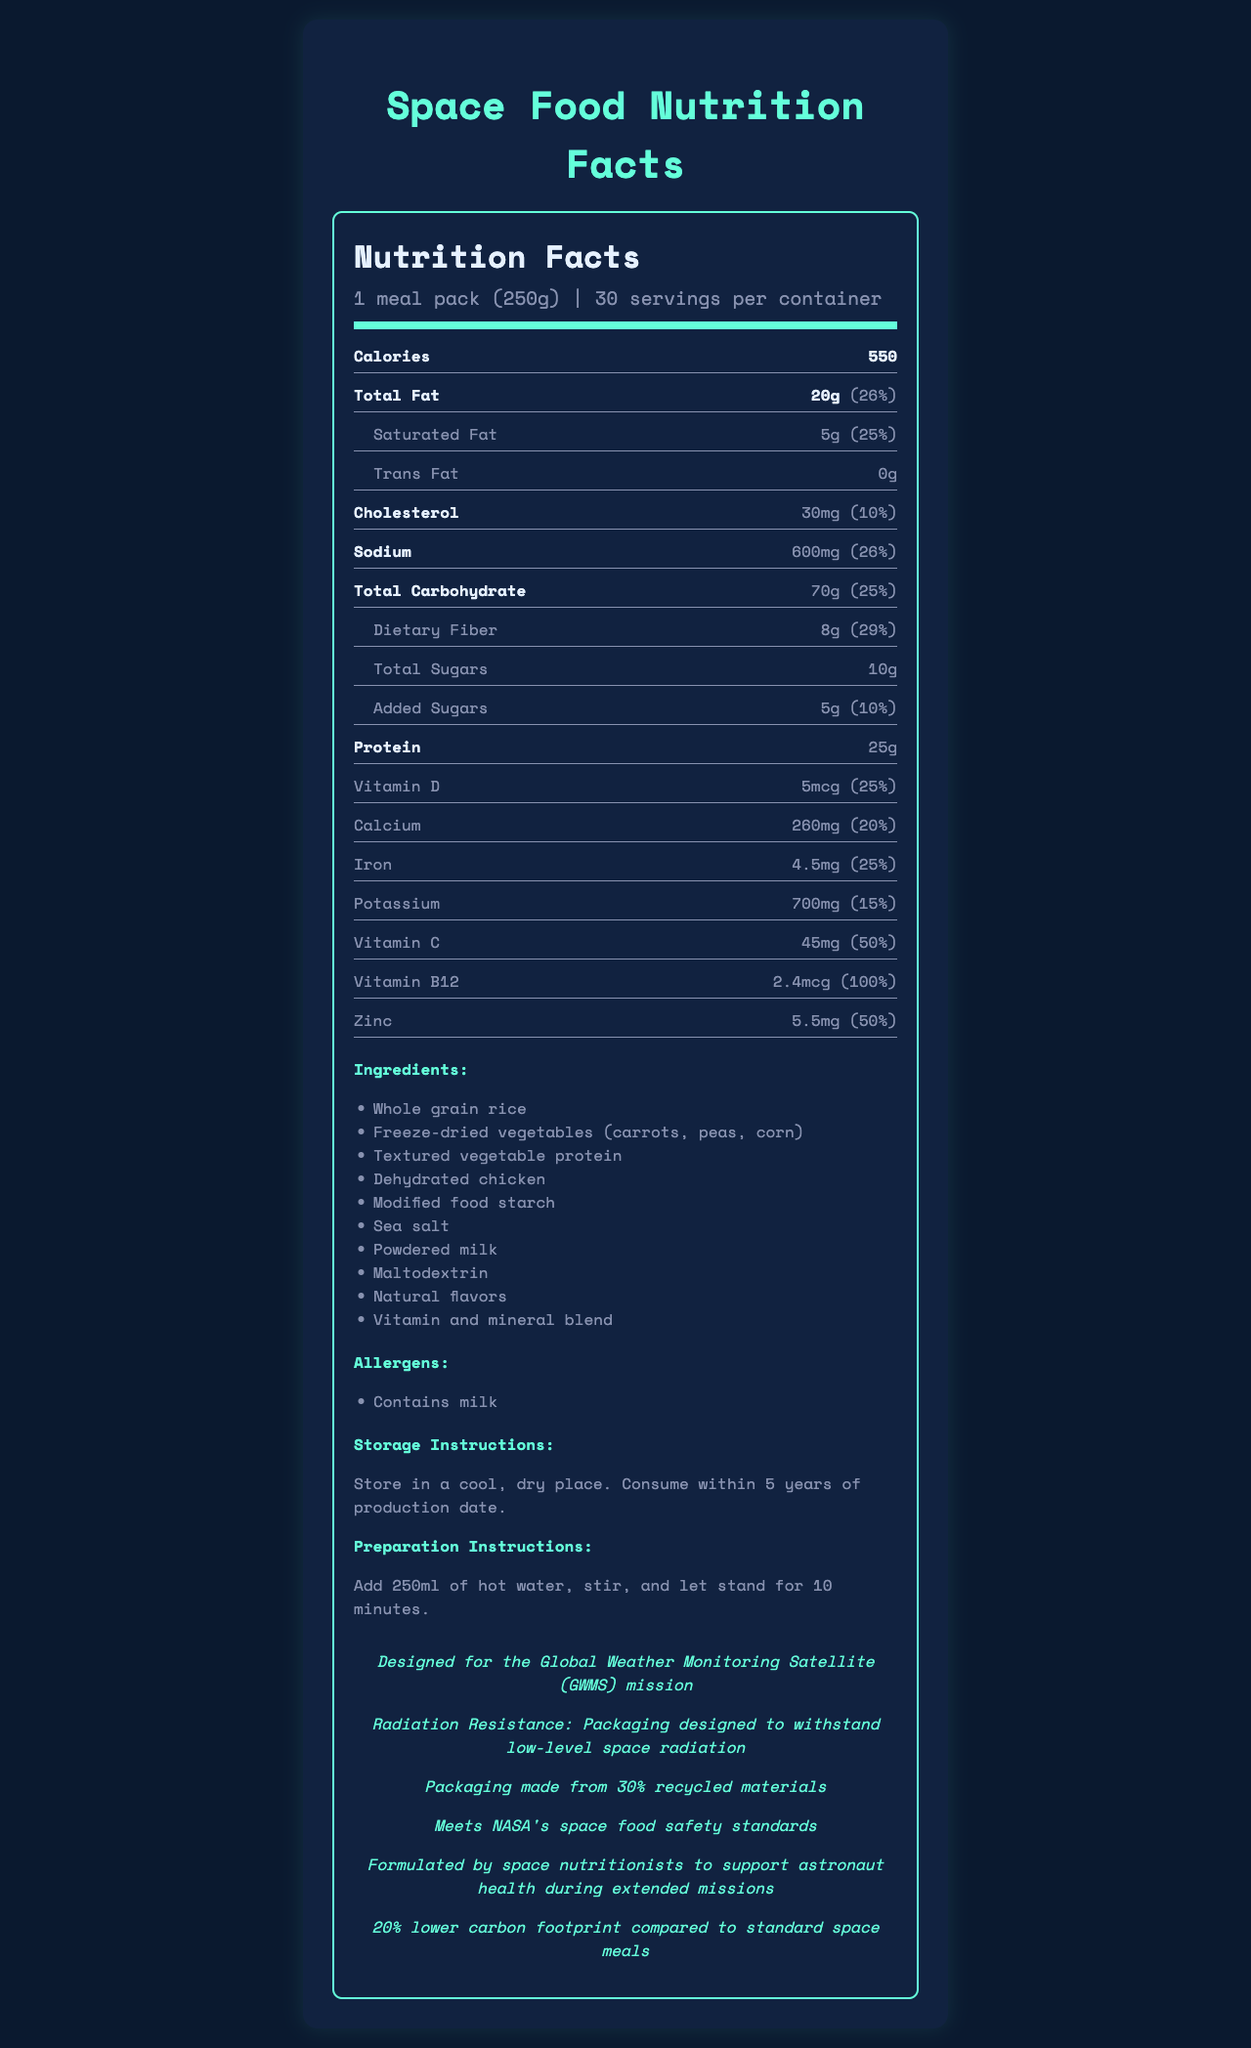what is the serving size of the meal pack? The serving size is clearly mentioned at the beginning of the document as "1 meal pack (250g)".
Answer: 1 meal pack (250g) how many servings are there per container? According to the document, each container has 30 servings.
Answer: 30 how many calories are there per serving? The document specifies that each serving contains 550 calories.
Answer: 550 calories what is the amount of protein per serving? Under the nutrition facts, the amount of protein is listed as 25g per serving.
Answer: 25g what is the percentage daily value of saturated fat per serving? The document indicates that the daily value percentage for saturated fat per serving is 25%.
Answer: 25% what are the storage instructions for the meal pack? The storage instructions are provided in the section near the end of the document.
Answer: Store in a cool, dry place. Consume within 5 years of production date. what are the main ingredients listed for the meal pack? The document has a detailed list of ingredients under the Ingredients section.
Answer: Whole grain rice, Freeze-dried vegetables (carrots, peas, corn), Textured vegetable protein, Dehydrated chicken, Modified food starch, Sea salt, Powdered milk, Maltodextrin, Natural flavors, Vitamin and mineral blend how many grams of total fat are there in a serving? The total fat content per serving is mentioned as 20g in the nutrition facts.
Answer: 20g how much sodium is in each serving? Sodium content per serving is stated as 600mg.
Answer: 600mg which vitamin has the highest daily value percentage in a single serving? A. Vitamin D B. Calcium C. Vitamin B12 D. Zinc The daily value percentage for Vitamin B12 is 100%, which is higher than the other listed vitamins.
Answer: C. Vitamin B12 which one of the following ingredients is NOT in the meal pack? i. Carrots ii. Peas iii. Beef The document lists the ingredients, and beef is not one of them, whereas carrots and peas are included.
Answer: iii. Beef Is there any trans fat in the meal pack? The document mentions that there is 0g of trans fat per serving.
Answer: No Does the meal pack contain any allergens? Under the Allergens section, it mentions that the meal pack contains milk.
Answer: Yes Summarize the main features of the document. The document offers extensive information about the meal pack, such as its nutritional content, ingredients, and additional mission-specific features, emphasizing its suitability for space missions.
Answer: The document provides detailed nutritional information for a space food meal pack designed for the Global Weather Monitoring Satellite mission. It includes serving size, calories, macronutrients, vitamins, minerals, ingredients, allergens, storage and preparation instructions, mission-specific details, and sustainability notes. The meal pack is formulated by space nutritionists to support astronaut health and meets NASA's safety standards. What is the main purpose of this document? The document provides nutritional and preparatory information about the meal pack but does not explicitly state its main purpose or the context in which it should be used.
Answer: Cannot be determined 